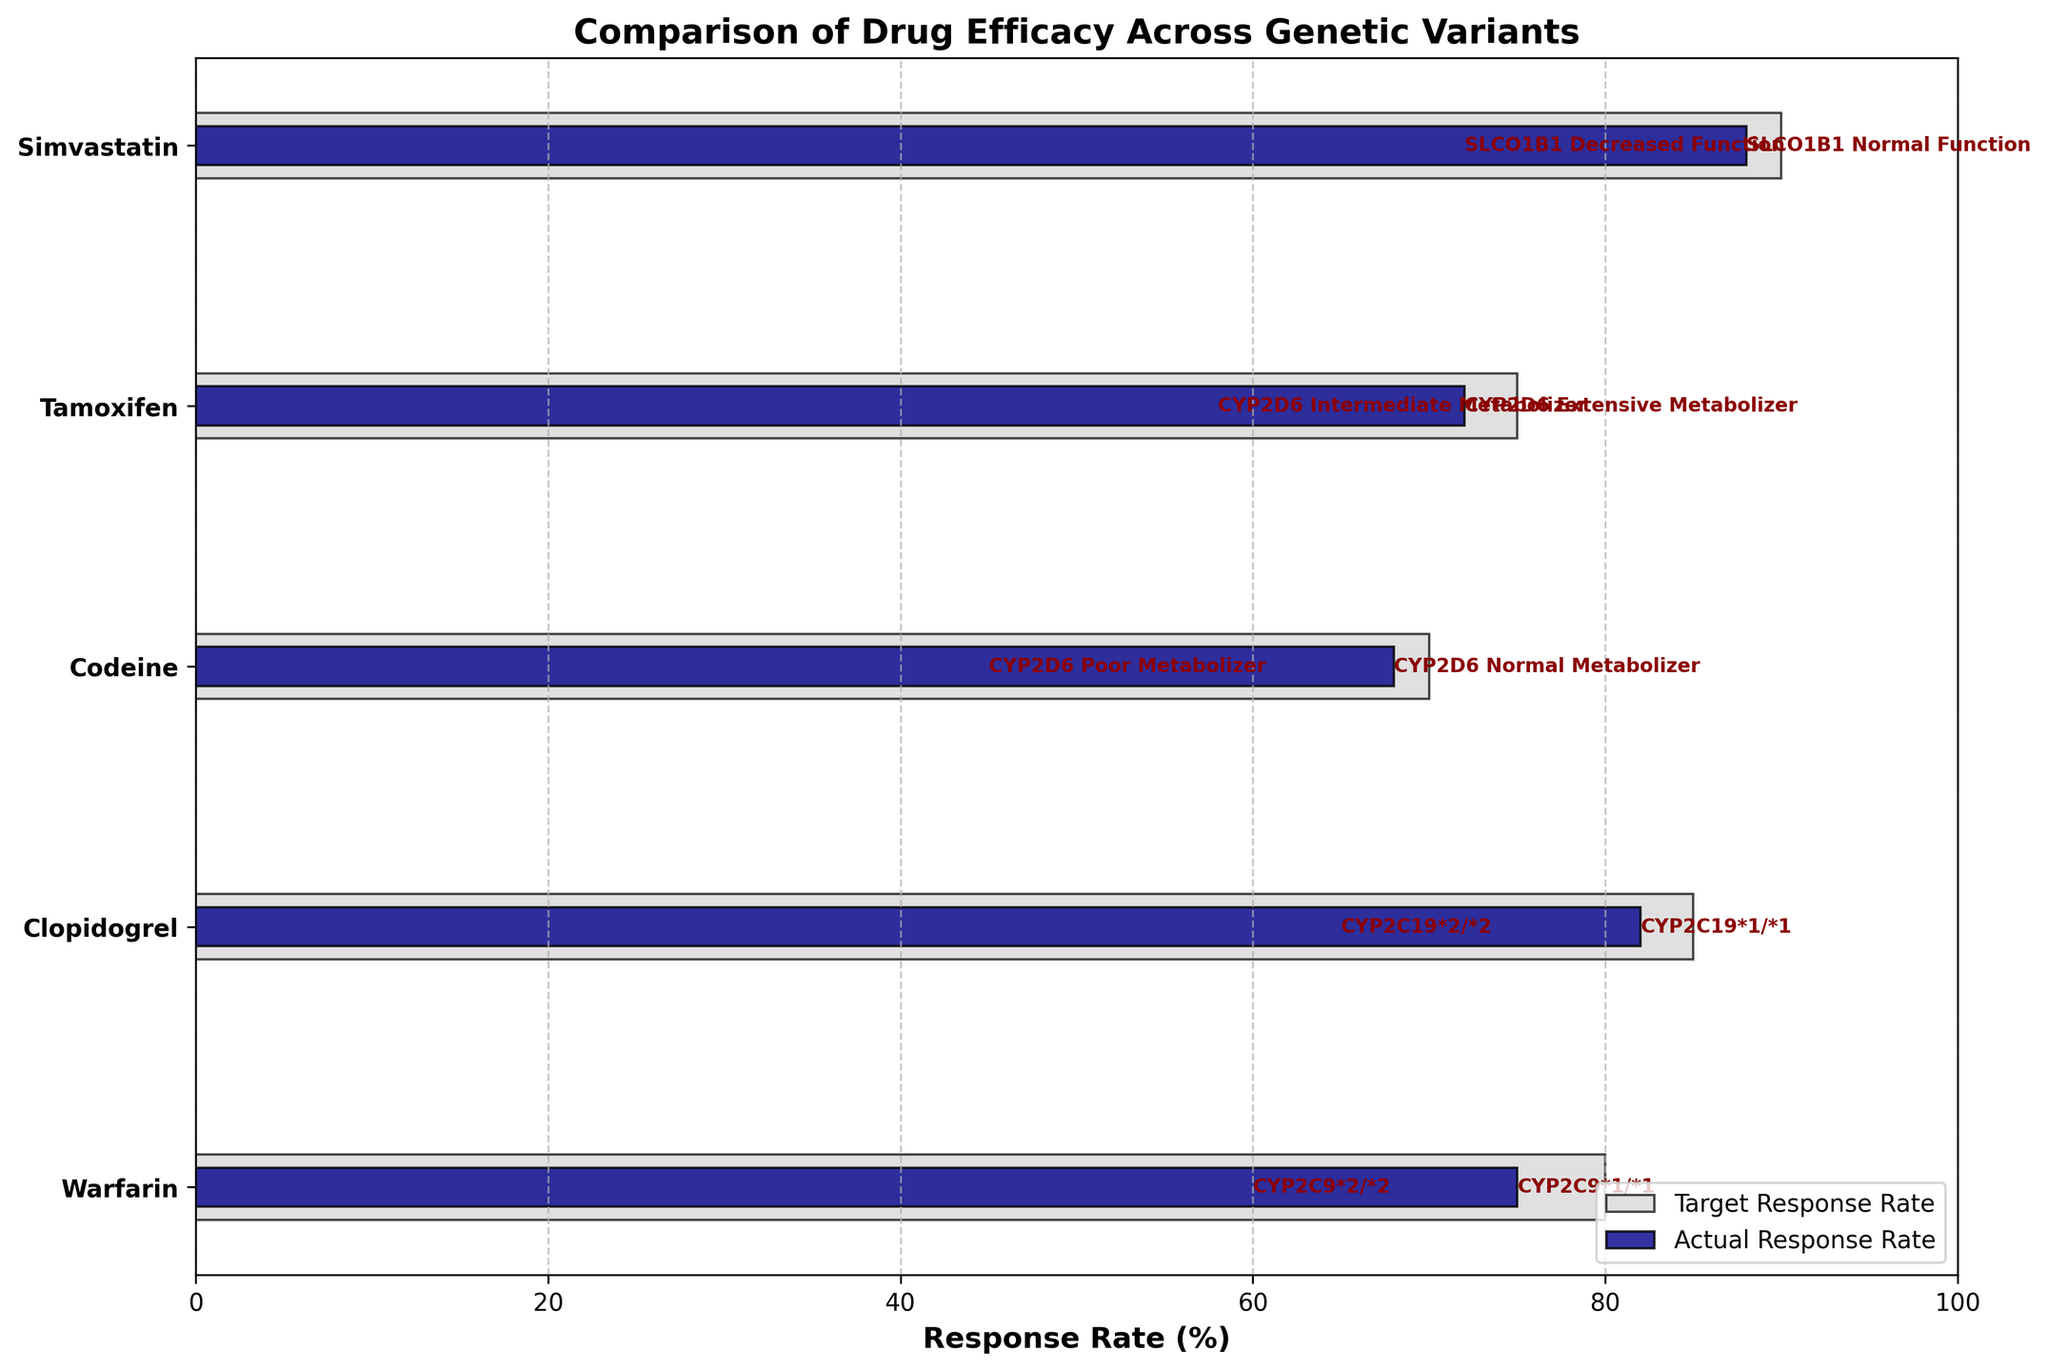Which drug has the highest target response rate? Look at the highest value in the 'Target Response Rate' on the x-axis and identify the corresponding drug. The highest target response rate is 90% for Simvastatin.
Answer: Simvastatin Which genetic variant of Clopidogrel has a lower actual response rate? Compare the actual response rates of the different CYP2C19 variants for Clopidogrel. CYP2C19*2/*2 has a lower actual response rate of 65%.
Answer: CYP2C19*2/*2 What's the difference between the target and actual response rates for Codeine in CYP2D6 Poor Metabolizer? Subtract the actual response rate from the target response rate for Codeine in CYP2D6 Poor Metabolizer: 70% - 45% = 25%.
Answer: 25% How many drugs have a target response rate of 80%? Count the number of drugs where the target response rate reaches 80%. Warfarin shows this target rate for both CYP2C9*1/*1 and CYP2C9*2/*2 variants.
Answer: 2 What drug shows the smallest gap between its target and actual response rates? Calculate the difference between the target and actual response rates for all drugs and find the smallest gap. Clopidogrel (CYP2C19*1/*1 variant) has a gap of 3% (85% - 82%).
Answer: Clopidogrel For which drug and genetic variant is the actual response rate closest to the target response rate? Look for the smallest difference between target and actual response rates across all drugs and genetic variants. Clopidogrel (CYP2C19*1/*1 variant) has the smallest difference of 3%.
Answer: Clopidogrel CYP2C19*1/*1 Which drug and variant combination has the largest actual response rate drop from its target? Find the combination with the largest difference between target and actual response rates. Simvastatin (SLCO1B1 Decreased Function) shows the largest drop, with a difference of 18% (90% - 72%).
Answer: Simvastatin SLCO1B1 Decreased Function 